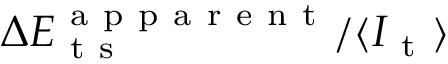Convert formula to latex. <formula><loc_0><loc_0><loc_500><loc_500>\Delta E _ { t s } ^ { a p p a r e n t } / \langle I _ { t } \rangle</formula> 